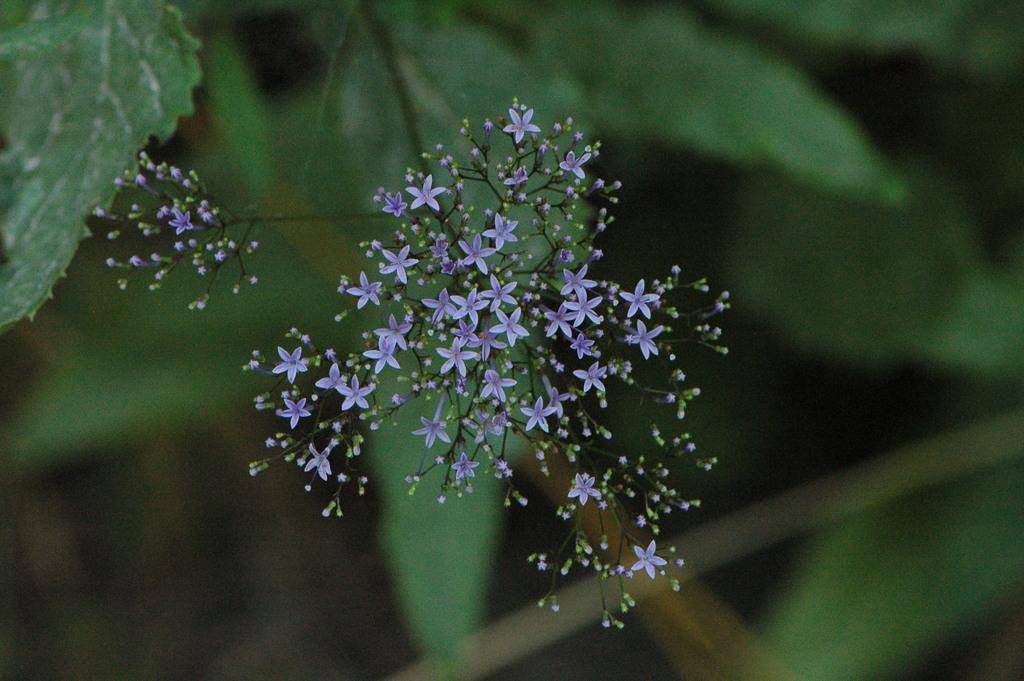In one or two sentences, can you explain what this image depicts? In the center of the image we can see flowers. In the background there are leaves. 